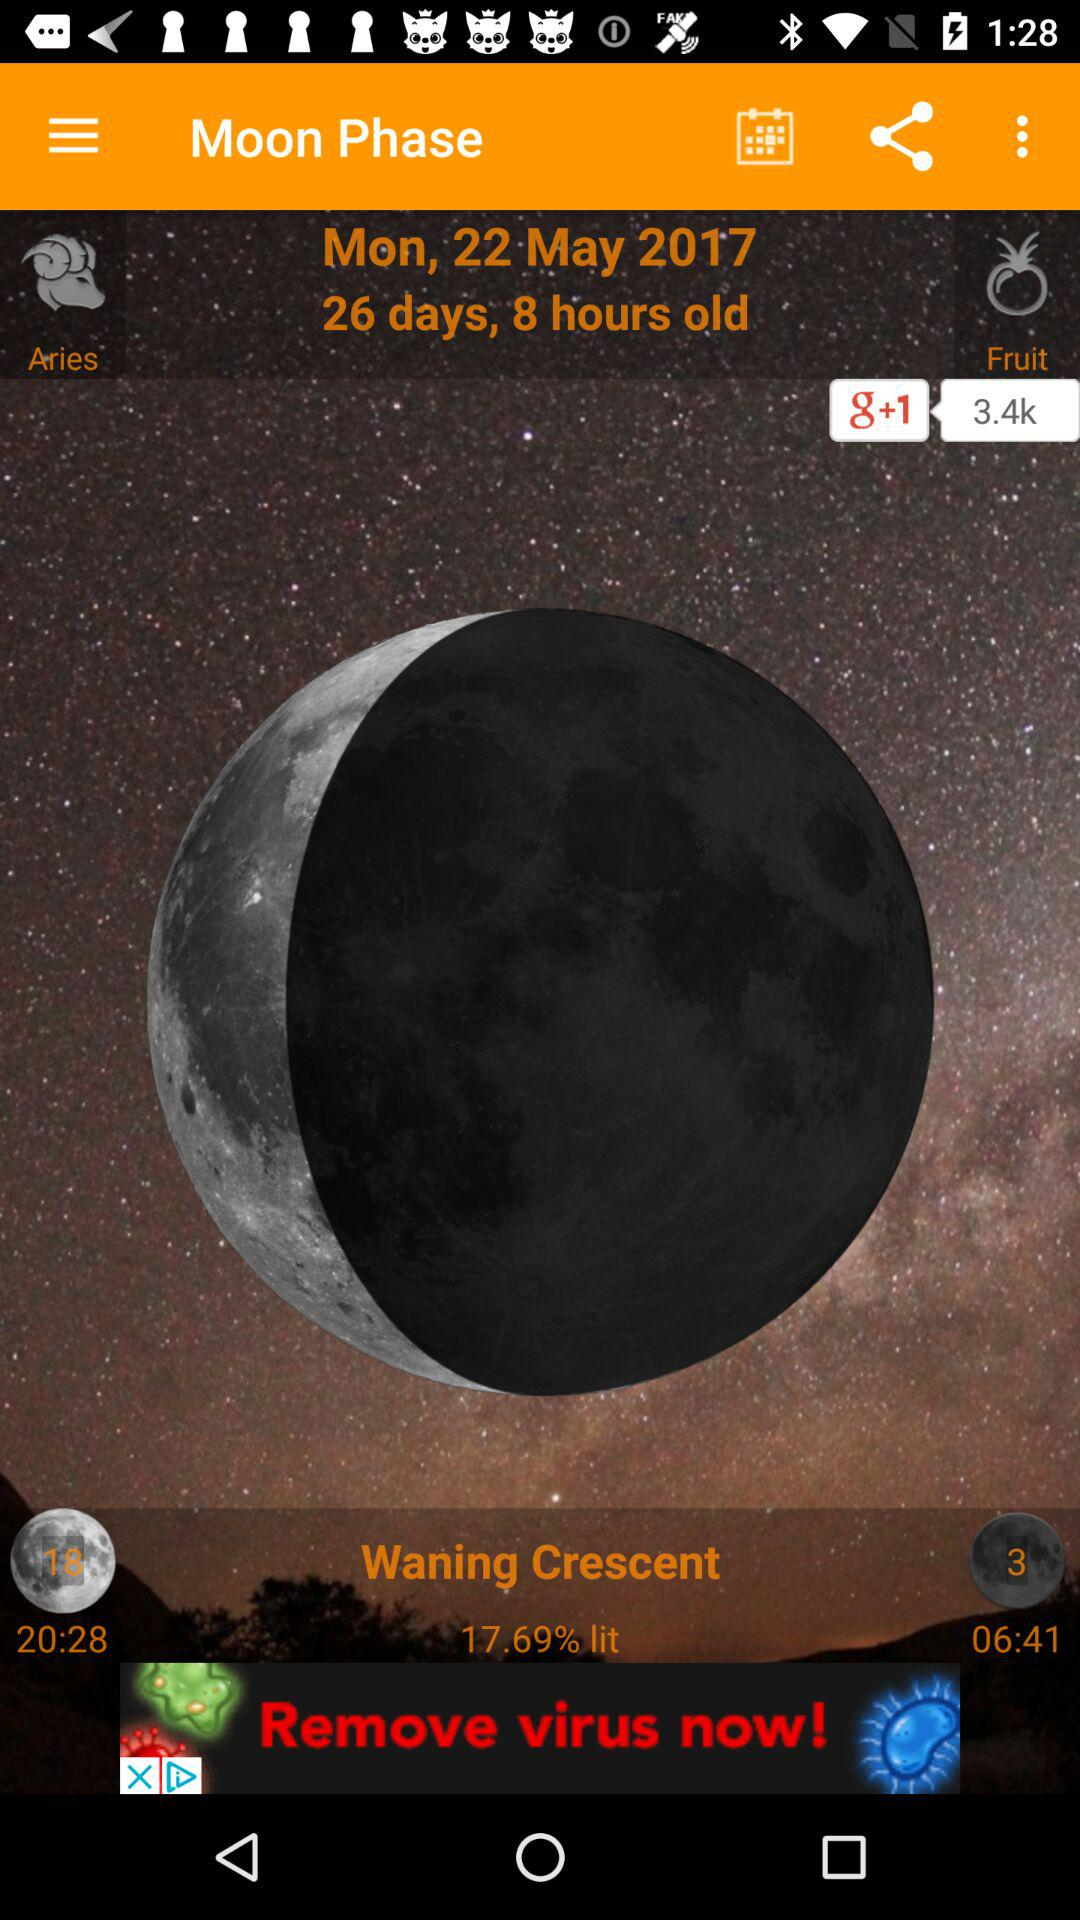How many days old is the moon phase? The moon phase is 26 days old. 